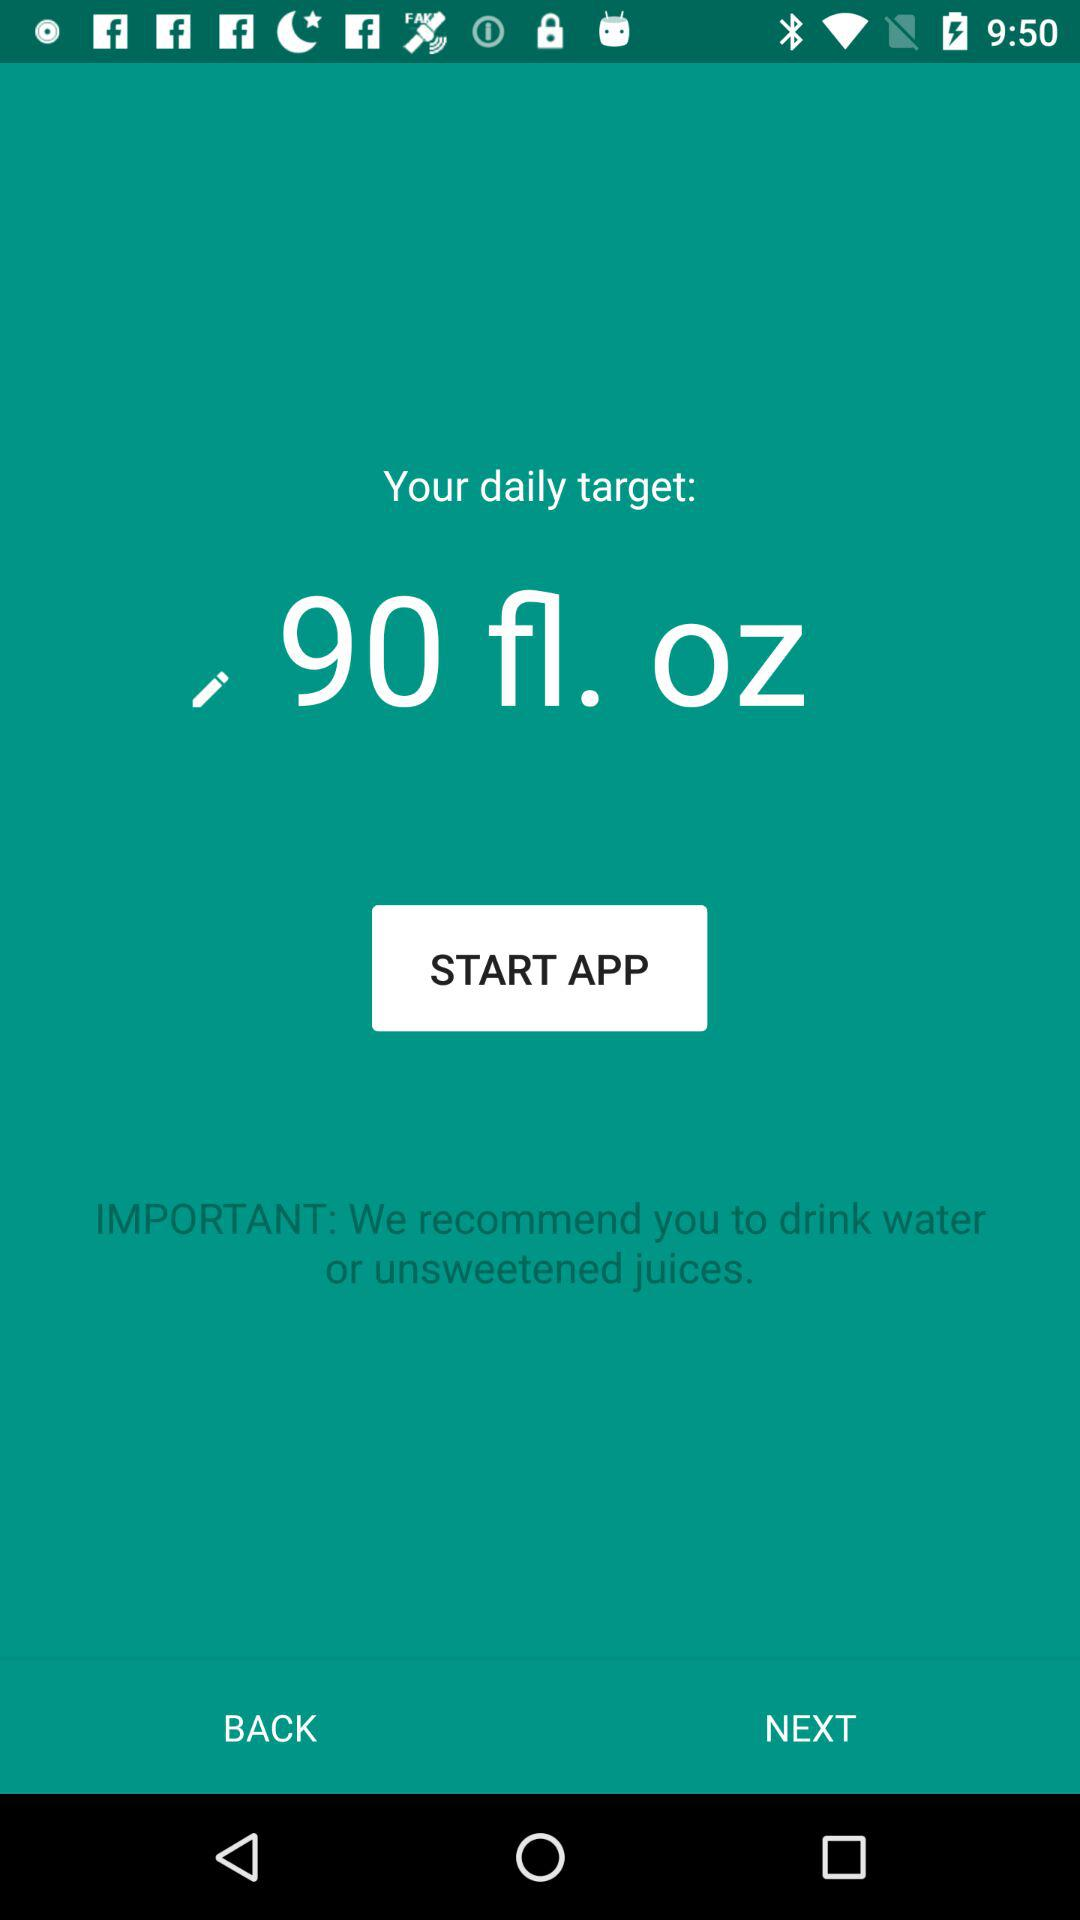How many fl. oz is the daily target?
Answer the question using a single word or phrase. 90 